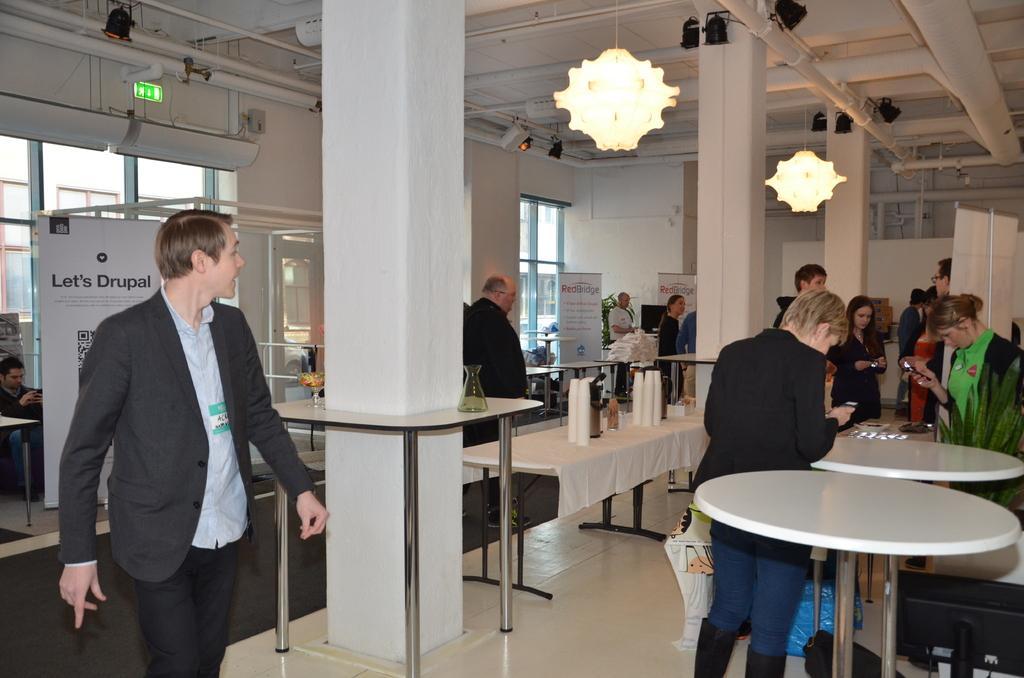Could you give a brief overview of what you see in this image? In the image there are some people stood around table , on ceiling there are lights, this looks like a break out hall. 